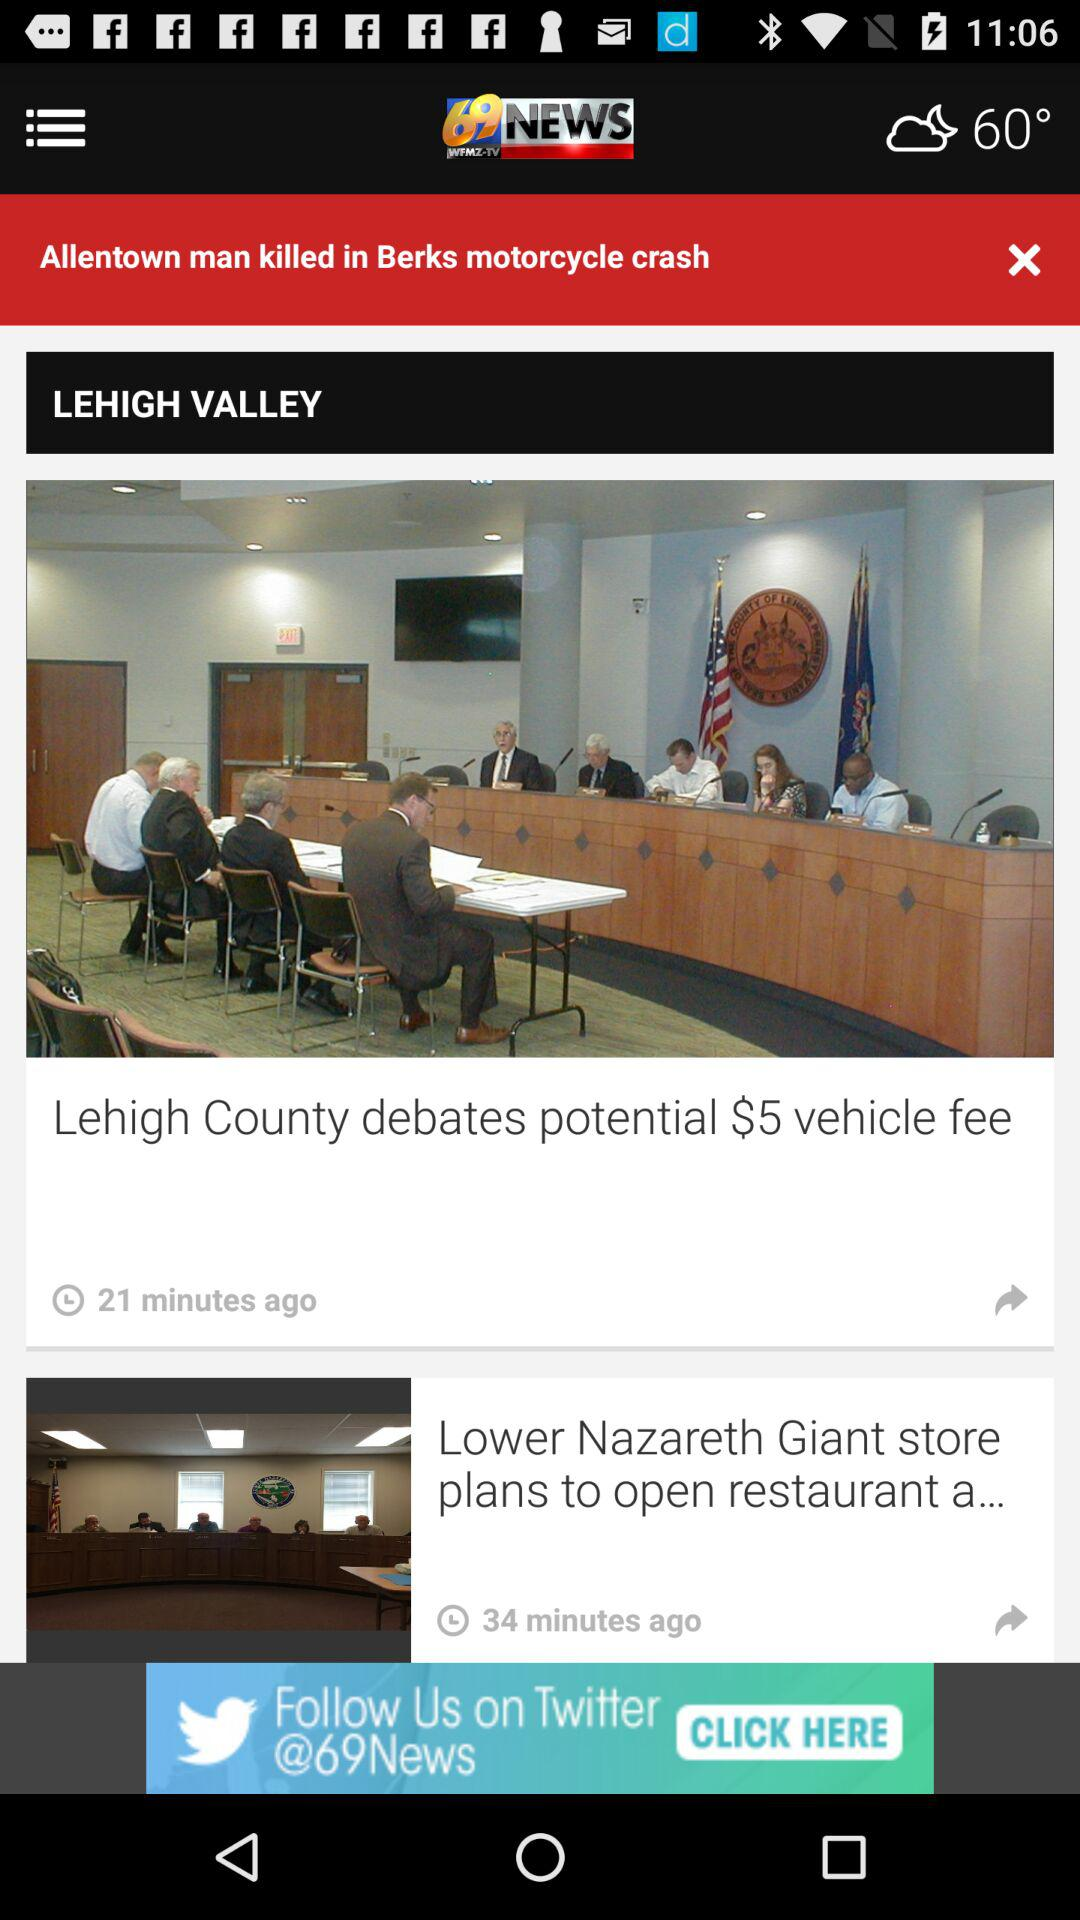When was the "Lehigh County debates potential $5 vehicle fee" news article published? The "Lehigh County debates potential $5 vehicle fee" news article was published 21 minutes ago. 